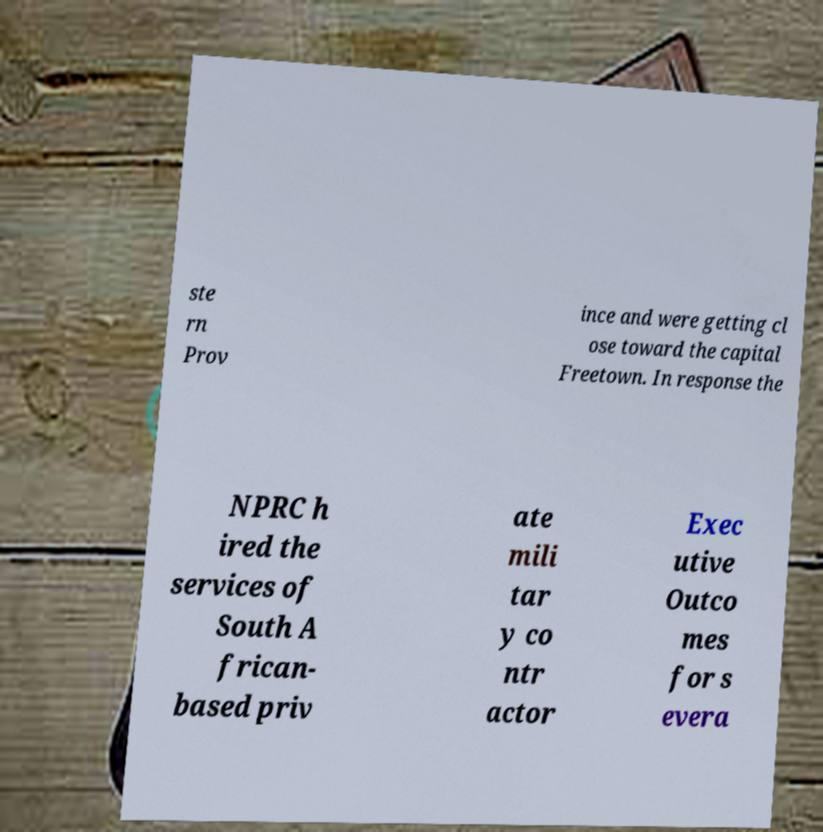Can you read and provide the text displayed in the image?This photo seems to have some interesting text. Can you extract and type it out for me? ste rn Prov ince and were getting cl ose toward the capital Freetown. In response the NPRC h ired the services of South A frican- based priv ate mili tar y co ntr actor Exec utive Outco mes for s evera 